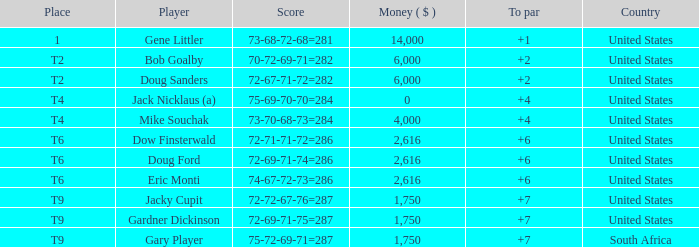What is the average To Par, when Score is "72-67-71-72=282"? 2.0. 